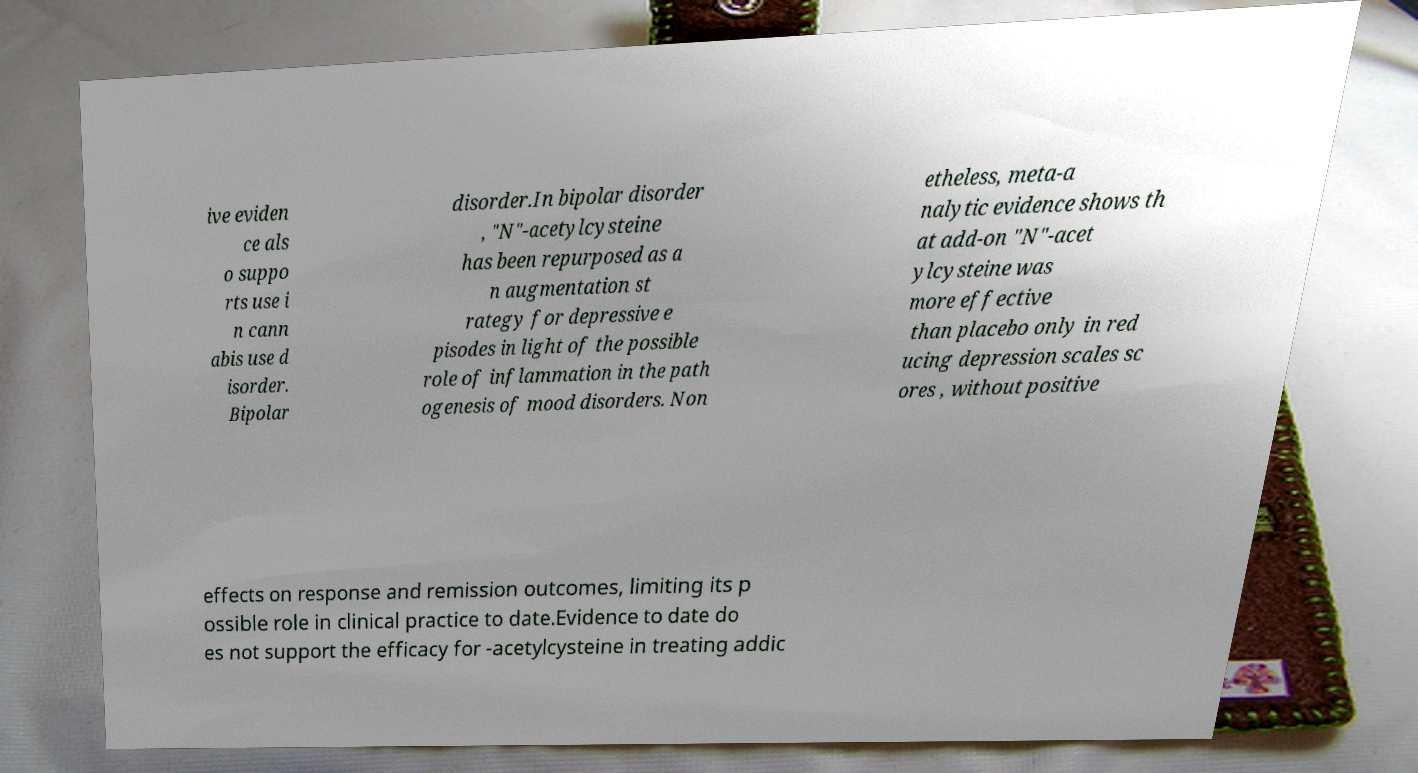Please read and relay the text visible in this image. What does it say? ive eviden ce als o suppo rts use i n cann abis use d isorder. Bipolar disorder.In bipolar disorder , "N"-acetylcysteine has been repurposed as a n augmentation st rategy for depressive e pisodes in light of the possible role of inflammation in the path ogenesis of mood disorders. Non etheless, meta-a nalytic evidence shows th at add-on "N"-acet ylcysteine was more effective than placebo only in red ucing depression scales sc ores , without positive effects on response and remission outcomes, limiting its p ossible role in clinical practice to date.Evidence to date do es not support the efficacy for -acetylcysteine in treating addic 